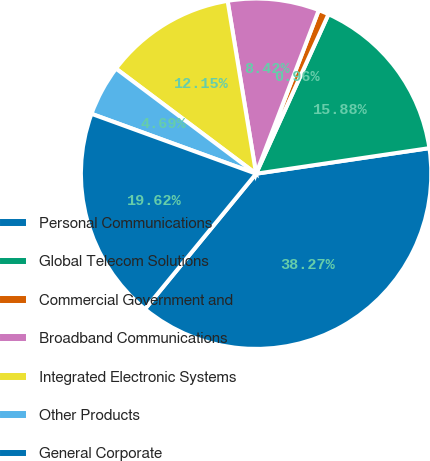Convert chart. <chart><loc_0><loc_0><loc_500><loc_500><pie_chart><fcel>Personal Communications<fcel>Global Telecom Solutions<fcel>Commercial Government and<fcel>Broadband Communications<fcel>Integrated Electronic Systems<fcel>Other Products<fcel>General Corporate<nl><fcel>38.26%<fcel>15.88%<fcel>0.96%<fcel>8.42%<fcel>12.15%<fcel>4.69%<fcel>19.61%<nl></chart> 